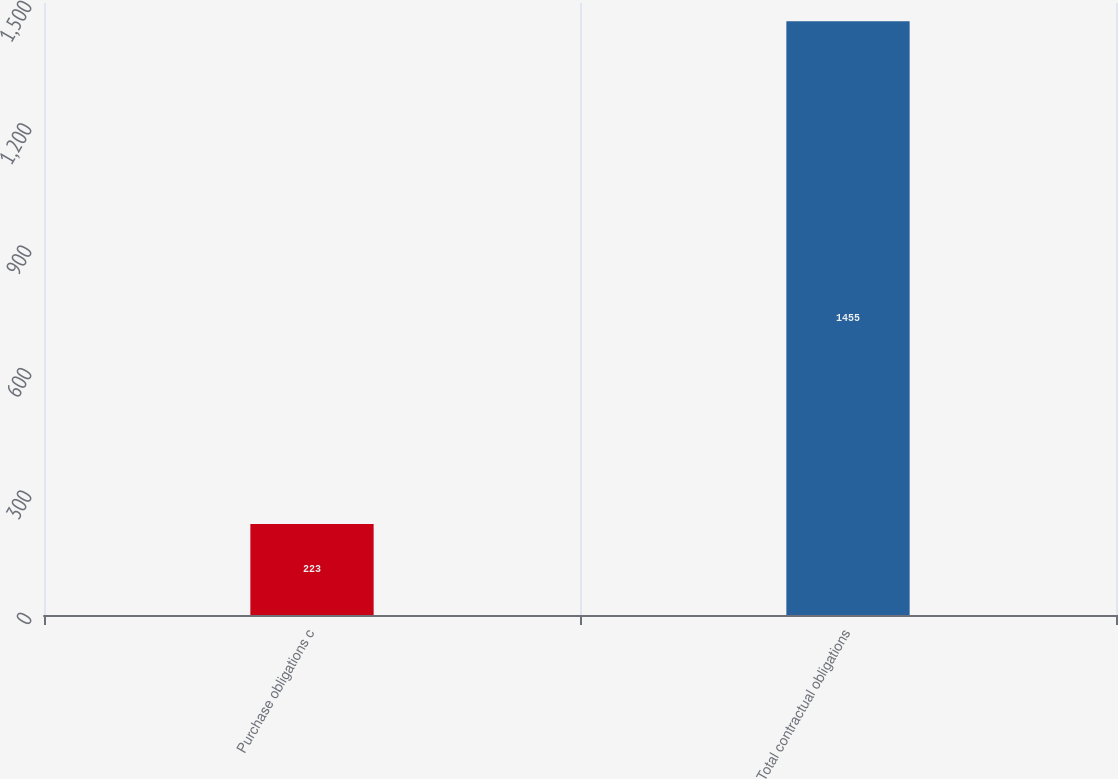Convert chart to OTSL. <chart><loc_0><loc_0><loc_500><loc_500><bar_chart><fcel>Purchase obligations c<fcel>Total contractual obligations<nl><fcel>223<fcel>1455<nl></chart> 